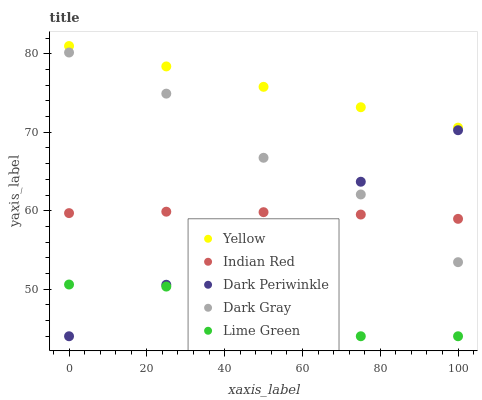Does Lime Green have the minimum area under the curve?
Answer yes or no. Yes. Does Yellow have the maximum area under the curve?
Answer yes or no. Yes. Does Indian Red have the minimum area under the curve?
Answer yes or no. No. Does Indian Red have the maximum area under the curve?
Answer yes or no. No. Is Dark Periwinkle the smoothest?
Answer yes or no. Yes. Is Dark Gray the roughest?
Answer yes or no. Yes. Is Lime Green the smoothest?
Answer yes or no. No. Is Lime Green the roughest?
Answer yes or no. No. Does Lime Green have the lowest value?
Answer yes or no. Yes. Does Indian Red have the lowest value?
Answer yes or no. No. Does Yellow have the highest value?
Answer yes or no. Yes. Does Indian Red have the highest value?
Answer yes or no. No. Is Lime Green less than Yellow?
Answer yes or no. Yes. Is Indian Red greater than Lime Green?
Answer yes or no. Yes. Does Dark Gray intersect Dark Periwinkle?
Answer yes or no. Yes. Is Dark Gray less than Dark Periwinkle?
Answer yes or no. No. Is Dark Gray greater than Dark Periwinkle?
Answer yes or no. No. Does Lime Green intersect Yellow?
Answer yes or no. No. 